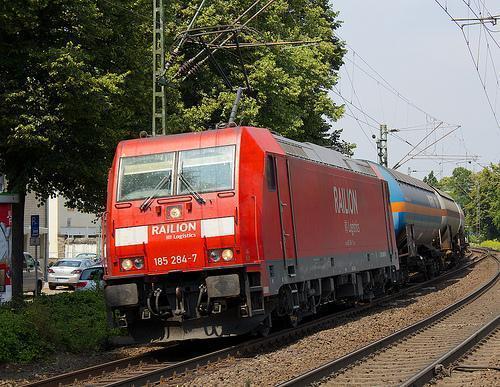How many windows are on the front of the train?
Give a very brief answer. 2. 